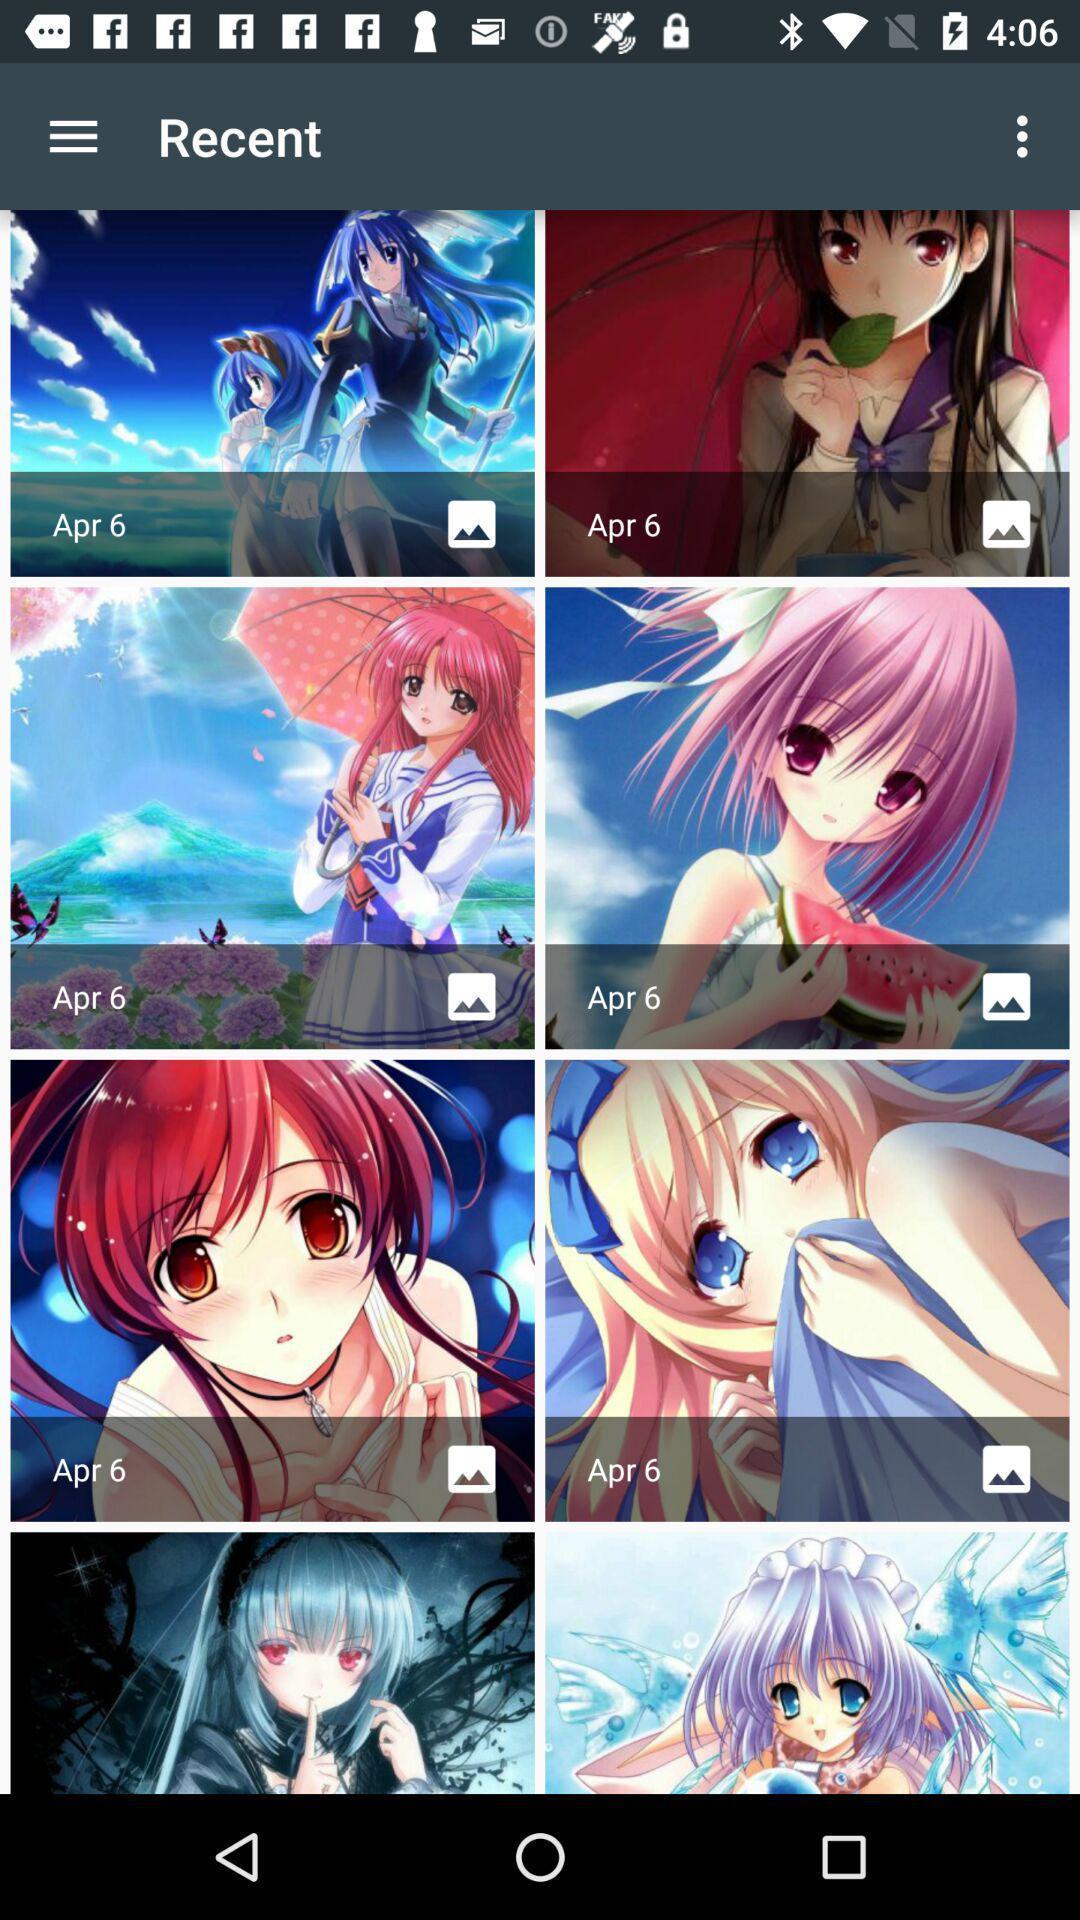Explain what's happening in this screen capture. Screen showing images. 